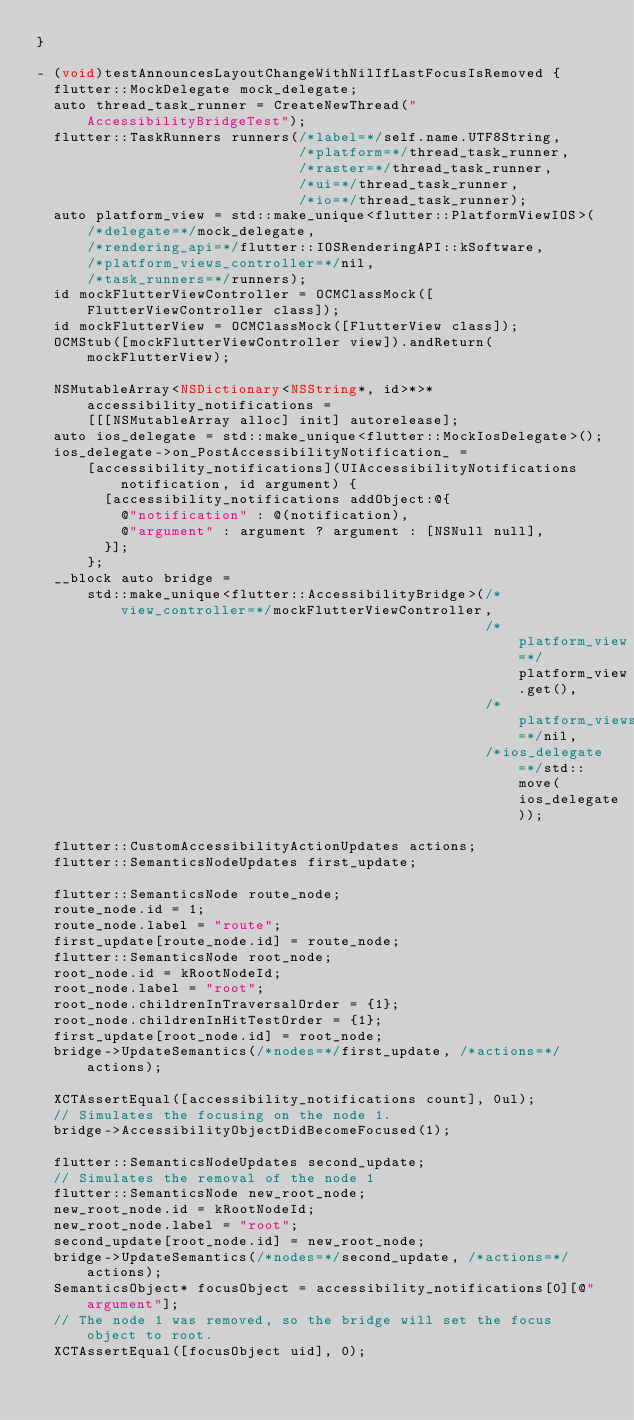Convert code to text. <code><loc_0><loc_0><loc_500><loc_500><_ObjectiveC_>}

- (void)testAnnouncesLayoutChangeWithNilIfLastFocusIsRemoved {
  flutter::MockDelegate mock_delegate;
  auto thread_task_runner = CreateNewThread("AccessibilityBridgeTest");
  flutter::TaskRunners runners(/*label=*/self.name.UTF8String,
                               /*platform=*/thread_task_runner,
                               /*raster=*/thread_task_runner,
                               /*ui=*/thread_task_runner,
                               /*io=*/thread_task_runner);
  auto platform_view = std::make_unique<flutter::PlatformViewIOS>(
      /*delegate=*/mock_delegate,
      /*rendering_api=*/flutter::IOSRenderingAPI::kSoftware,
      /*platform_views_controller=*/nil,
      /*task_runners=*/runners);
  id mockFlutterViewController = OCMClassMock([FlutterViewController class]);
  id mockFlutterView = OCMClassMock([FlutterView class]);
  OCMStub([mockFlutterViewController view]).andReturn(mockFlutterView);

  NSMutableArray<NSDictionary<NSString*, id>*>* accessibility_notifications =
      [[[NSMutableArray alloc] init] autorelease];
  auto ios_delegate = std::make_unique<flutter::MockIosDelegate>();
  ios_delegate->on_PostAccessibilityNotification_ =
      [accessibility_notifications](UIAccessibilityNotifications notification, id argument) {
        [accessibility_notifications addObject:@{
          @"notification" : @(notification),
          @"argument" : argument ? argument : [NSNull null],
        }];
      };
  __block auto bridge =
      std::make_unique<flutter::AccessibilityBridge>(/*view_controller=*/mockFlutterViewController,
                                                     /*platform_view=*/platform_view.get(),
                                                     /*platform_views_controller=*/nil,
                                                     /*ios_delegate=*/std::move(ios_delegate));

  flutter::CustomAccessibilityActionUpdates actions;
  flutter::SemanticsNodeUpdates first_update;

  flutter::SemanticsNode route_node;
  route_node.id = 1;
  route_node.label = "route";
  first_update[route_node.id] = route_node;
  flutter::SemanticsNode root_node;
  root_node.id = kRootNodeId;
  root_node.label = "root";
  root_node.childrenInTraversalOrder = {1};
  root_node.childrenInHitTestOrder = {1};
  first_update[root_node.id] = root_node;
  bridge->UpdateSemantics(/*nodes=*/first_update, /*actions=*/actions);

  XCTAssertEqual([accessibility_notifications count], 0ul);
  // Simulates the focusing on the node 1.
  bridge->AccessibilityObjectDidBecomeFocused(1);

  flutter::SemanticsNodeUpdates second_update;
  // Simulates the removal of the node 1
  flutter::SemanticsNode new_root_node;
  new_root_node.id = kRootNodeId;
  new_root_node.label = "root";
  second_update[root_node.id] = new_root_node;
  bridge->UpdateSemantics(/*nodes=*/second_update, /*actions=*/actions);
  SemanticsObject* focusObject = accessibility_notifications[0][@"argument"];
  // The node 1 was removed, so the bridge will set the focus object to root.
  XCTAssertEqual([focusObject uid], 0);</code> 